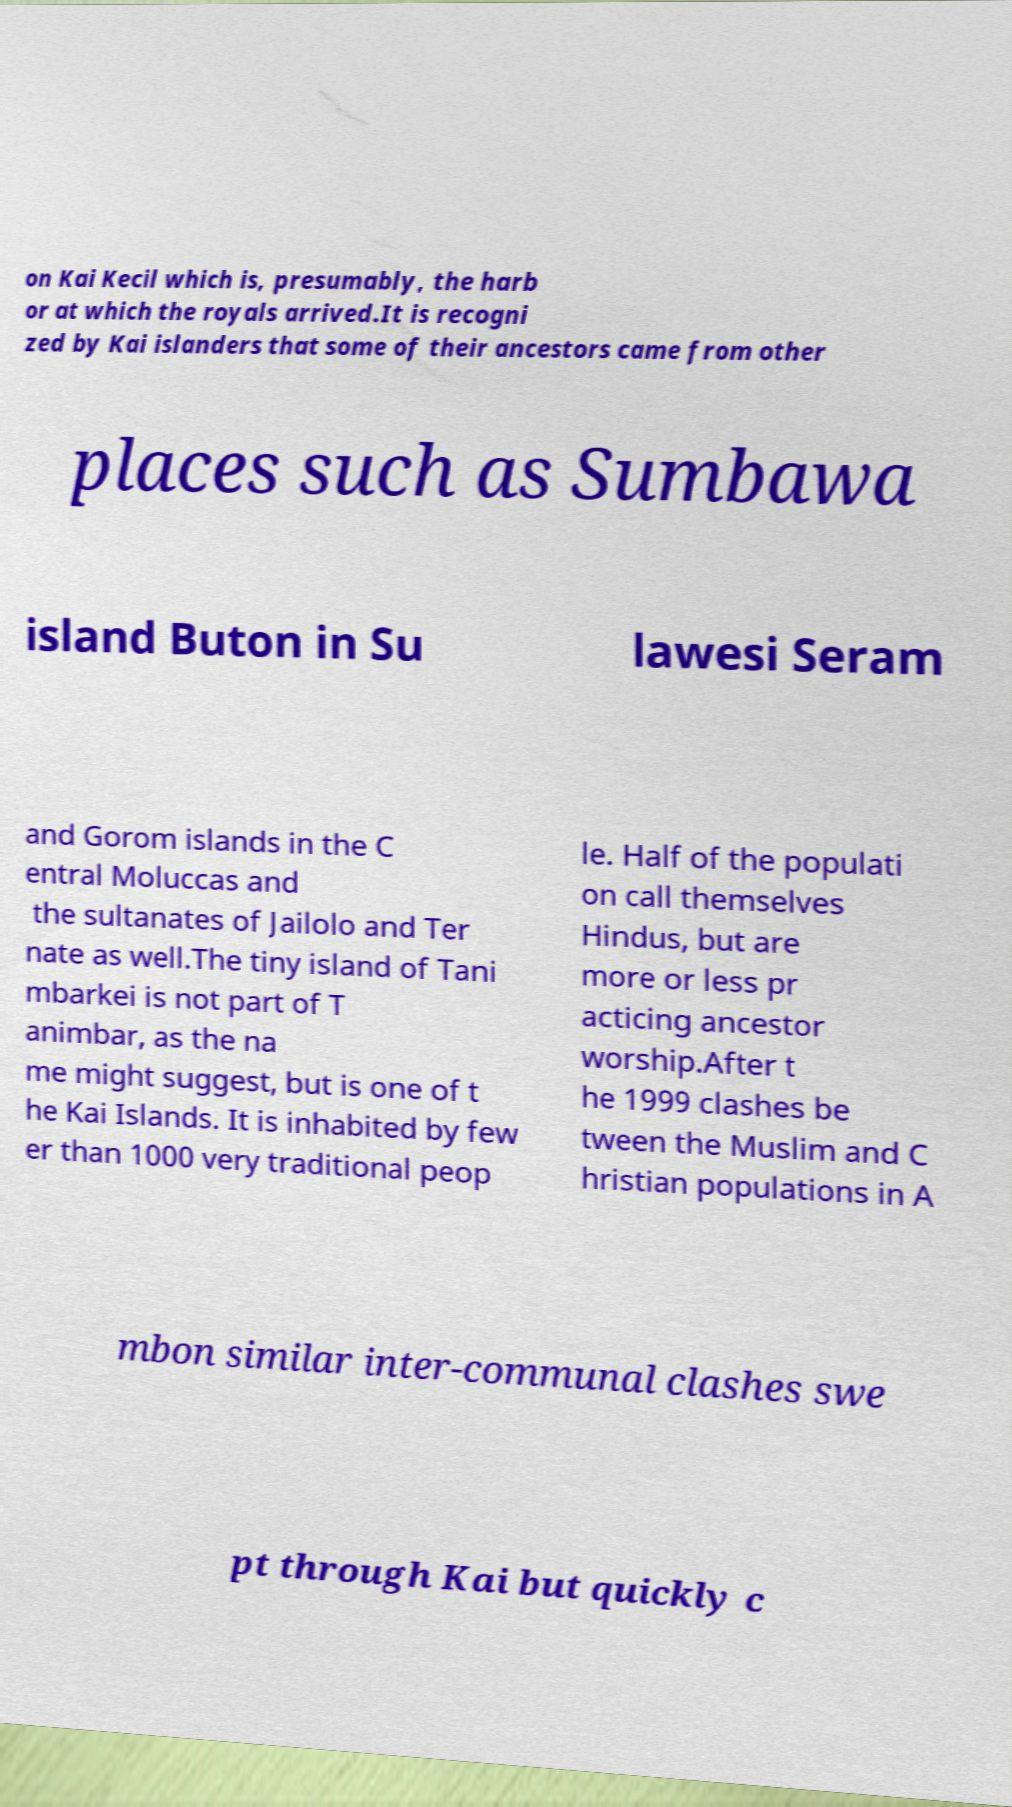What messages or text are displayed in this image? I need them in a readable, typed format. on Kai Kecil which is, presumably, the harb or at which the royals arrived.It is recogni zed by Kai islanders that some of their ancestors came from other places such as Sumbawa island Buton in Su lawesi Seram and Gorom islands in the C entral Moluccas and the sultanates of Jailolo and Ter nate as well.The tiny island of Tani mbarkei is not part of T animbar, as the na me might suggest, but is one of t he Kai Islands. It is inhabited by few er than 1000 very traditional peop le. Half of the populati on call themselves Hindus, but are more or less pr acticing ancestor worship.After t he 1999 clashes be tween the Muslim and C hristian populations in A mbon similar inter-communal clashes swe pt through Kai but quickly c 